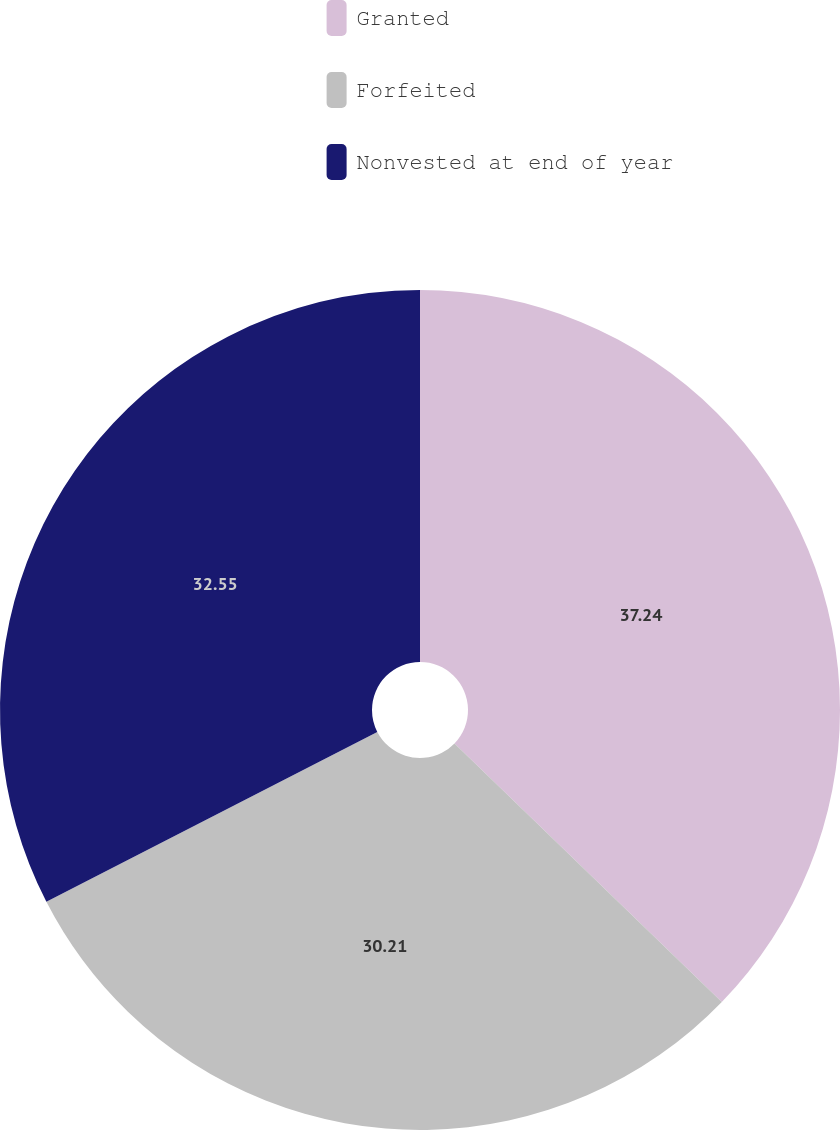Convert chart. <chart><loc_0><loc_0><loc_500><loc_500><pie_chart><fcel>Granted<fcel>Forfeited<fcel>Nonvested at end of year<nl><fcel>37.24%<fcel>30.21%<fcel>32.55%<nl></chart> 